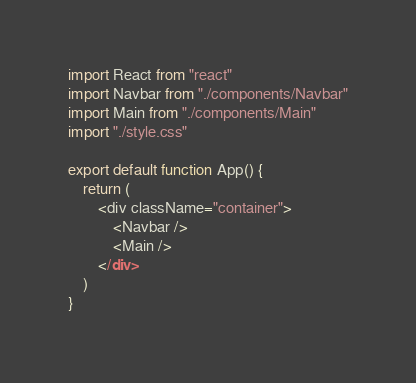Convert code to text. <code><loc_0><loc_0><loc_500><loc_500><_JavaScript_>import React from "react"
import Navbar from "./components/Navbar"
import Main from "./components/Main"
import "./style.css"

export default function App() {
    return (
        <div className="container">
            <Navbar />
            <Main />
        </div>
    )
}
</code> 